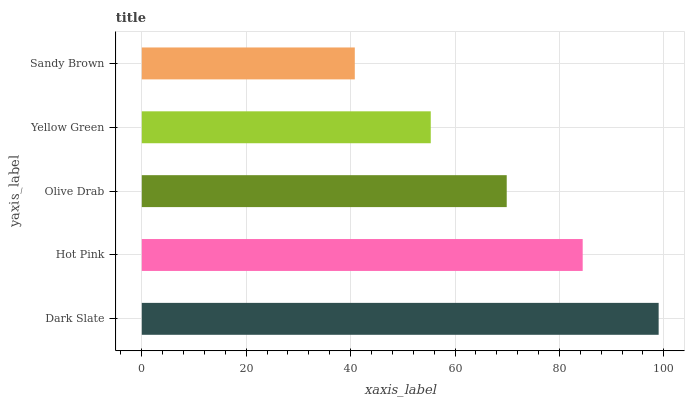Is Sandy Brown the minimum?
Answer yes or no. Yes. Is Dark Slate the maximum?
Answer yes or no. Yes. Is Hot Pink the minimum?
Answer yes or no. No. Is Hot Pink the maximum?
Answer yes or no. No. Is Dark Slate greater than Hot Pink?
Answer yes or no. Yes. Is Hot Pink less than Dark Slate?
Answer yes or no. Yes. Is Hot Pink greater than Dark Slate?
Answer yes or no. No. Is Dark Slate less than Hot Pink?
Answer yes or no. No. Is Olive Drab the high median?
Answer yes or no. Yes. Is Olive Drab the low median?
Answer yes or no. Yes. Is Yellow Green the high median?
Answer yes or no. No. Is Dark Slate the low median?
Answer yes or no. No. 